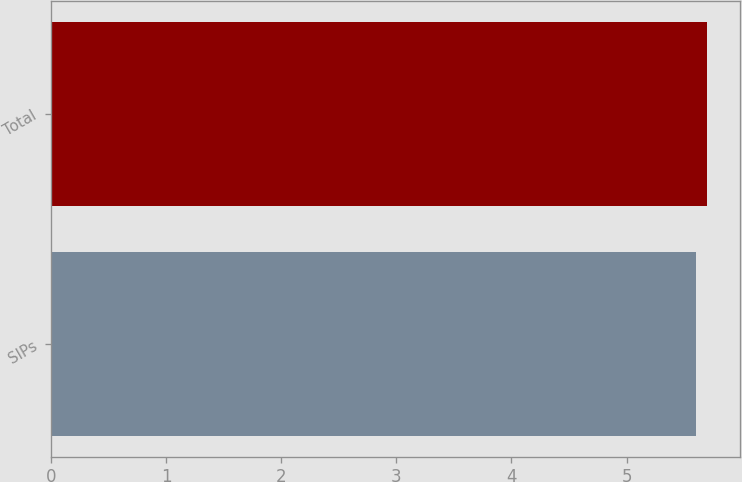Convert chart. <chart><loc_0><loc_0><loc_500><loc_500><bar_chart><fcel>SIPs<fcel>Total<nl><fcel>5.6<fcel>5.7<nl></chart> 